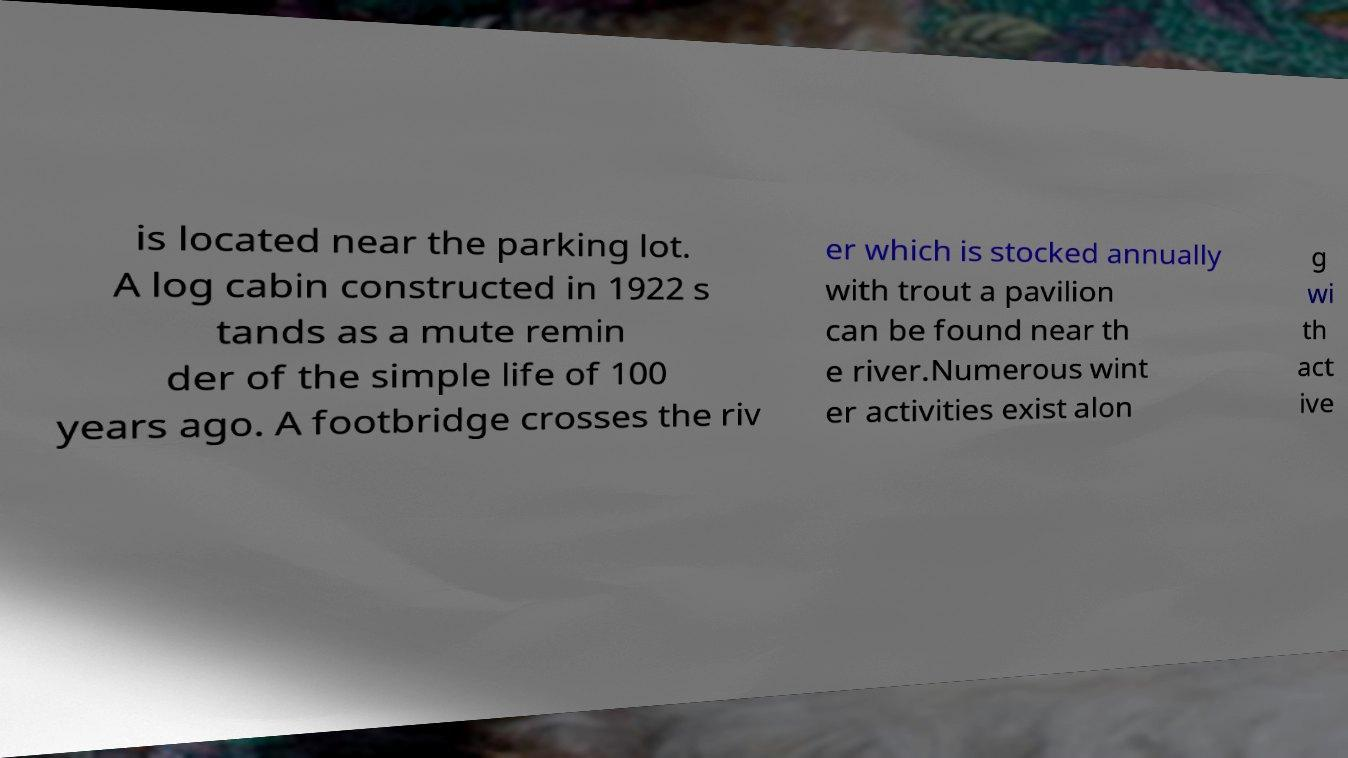Could you assist in decoding the text presented in this image and type it out clearly? is located near the parking lot. A log cabin constructed in 1922 s tands as a mute remin der of the simple life of 100 years ago. A footbridge crosses the riv er which is stocked annually with trout a pavilion can be found near th e river.Numerous wint er activities exist alon g wi th act ive 